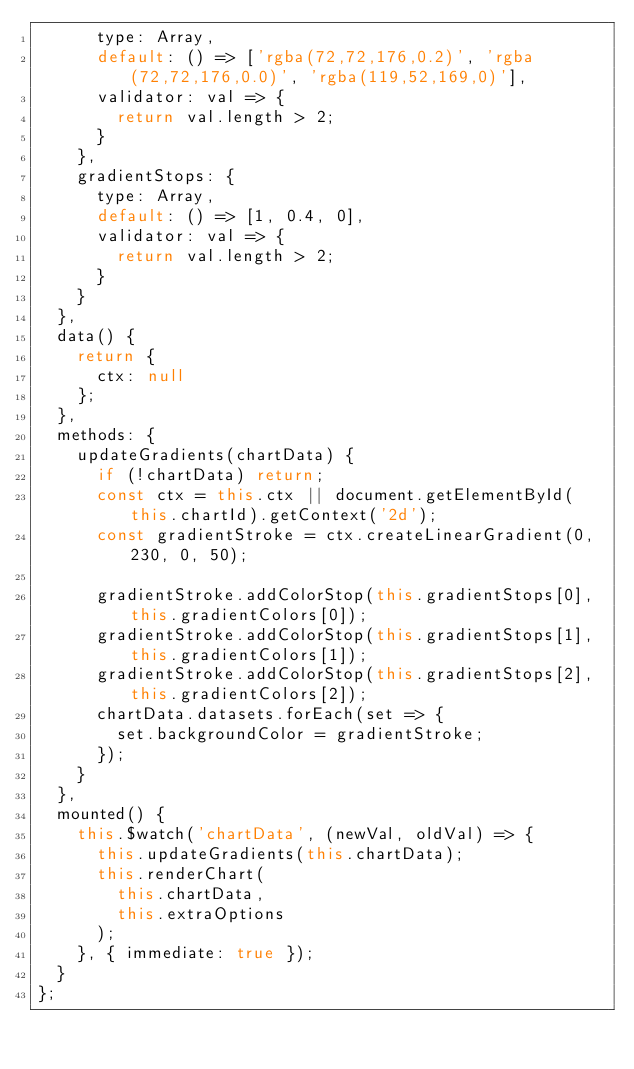<code> <loc_0><loc_0><loc_500><loc_500><_JavaScript_>      type: Array,
      default: () => ['rgba(72,72,176,0.2)', 'rgba(72,72,176,0.0)', 'rgba(119,52,169,0)'],
      validator: val => {
        return val.length > 2;
      }
    },
    gradientStops: {
      type: Array,
      default: () => [1, 0.4, 0],
      validator: val => {
        return val.length > 2;
      }
    }
  },
  data() {
    return {
      ctx: null
    };
  },
  methods: {
    updateGradients(chartData) {
      if (!chartData) return;
      const ctx = this.ctx || document.getElementById(this.chartId).getContext('2d');
      const gradientStroke = ctx.createLinearGradient(0, 230, 0, 50);

      gradientStroke.addColorStop(this.gradientStops[0], this.gradientColors[0]);
      gradientStroke.addColorStop(this.gradientStops[1], this.gradientColors[1]);
      gradientStroke.addColorStop(this.gradientStops[2], this.gradientColors[2]);
      chartData.datasets.forEach(set => {
        set.backgroundColor = gradientStroke;
      });
    }
  },
  mounted() {
    this.$watch('chartData', (newVal, oldVal) => {
      this.updateGradients(this.chartData);
      this.renderChart(
        this.chartData,
        this.extraOptions
      );
    }, { immediate: true });
  }
};
</code> 